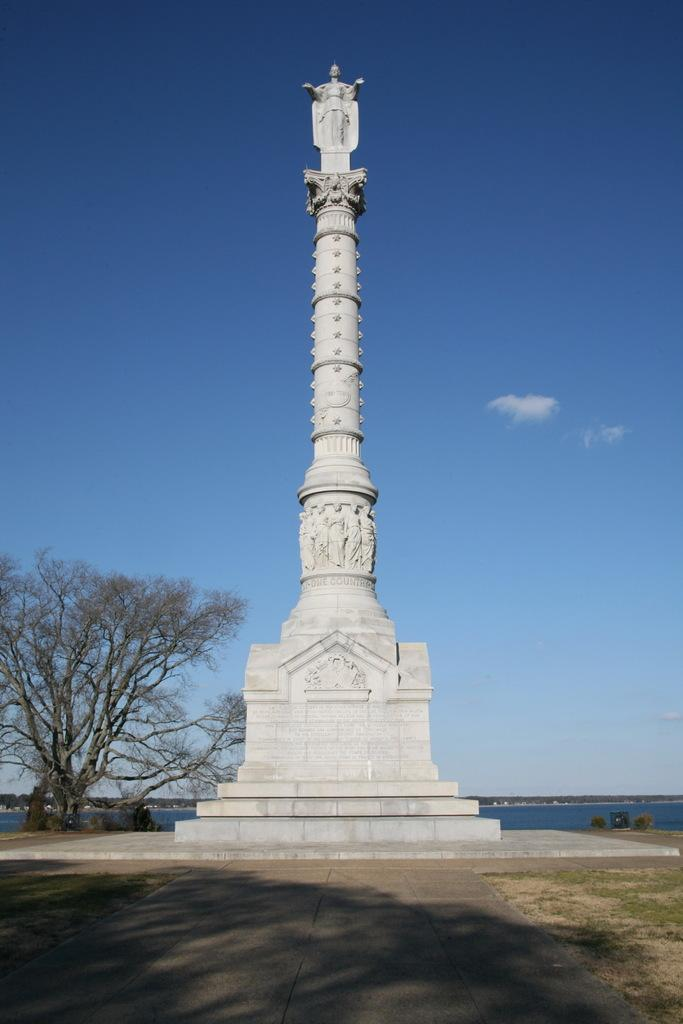What is the main structure in the image? There is a victory monument in the image. What type of vegetation can be seen in the image? There is grass in the image. Is there any pathway visible in the image? Yes, there is a footpath in the image. What other natural elements can be seen in the image? There is a tree and water visible in the image. What part of the natural environment is visible in the image? The sky is visible in the image. What type of spark can be seen in the image? There is no spark present in the image. --- Facts: 1. There is a person in the image. 2. The person is wearing a hat. 3. The person is holding a book. 4. The person is sitting on a bench. 5. There is a tree in the background. 6. The sky is visible in the image. Absurd Topics: unicorn, parachute, volcano Conversation: Who or what is in the image? There is a person in the image. What is the person wearing? The person is wearing a hat. What is the person holding? The person is holding a book. What is the person doing? The person is sitting on a bench. What can be seen in the background? There is a tree in the background. What part of the natural environment is visible in the image? The sky is visible in the image. Reasoning: Let's think step by step in order to produce the conversation. We start by identifying the main subject in the image, which is the person. Then, we describe specific details about the person, such as their clothing (a hat) and what they are holding (a book). Next, we observe the person's actions (sitting on a bench). After that, we describe the background elements (a tree). Finally, we describe the sky's condition (visible). Absurd Question/Answer: Can you see a unicorn in the image? There is no unicorn present in the image. --- Facts: 1. There is a dog in the image. 2. The dog is lying down. 3. The dog is wearing a collar. 4. There is a bowl of water next to the dog. 5. There is a fence in the background. 6. The grass is visible in the image. Absurd Topics: spaceship, alien, telescope Conversation: What type of animal is in the image? There is a dog in the image. What position is the dog in? The dog is lying down. What is the dog wearing? The dog is wearing a collar. What object is next to the dog? There is a bowl of water next to the dog. 